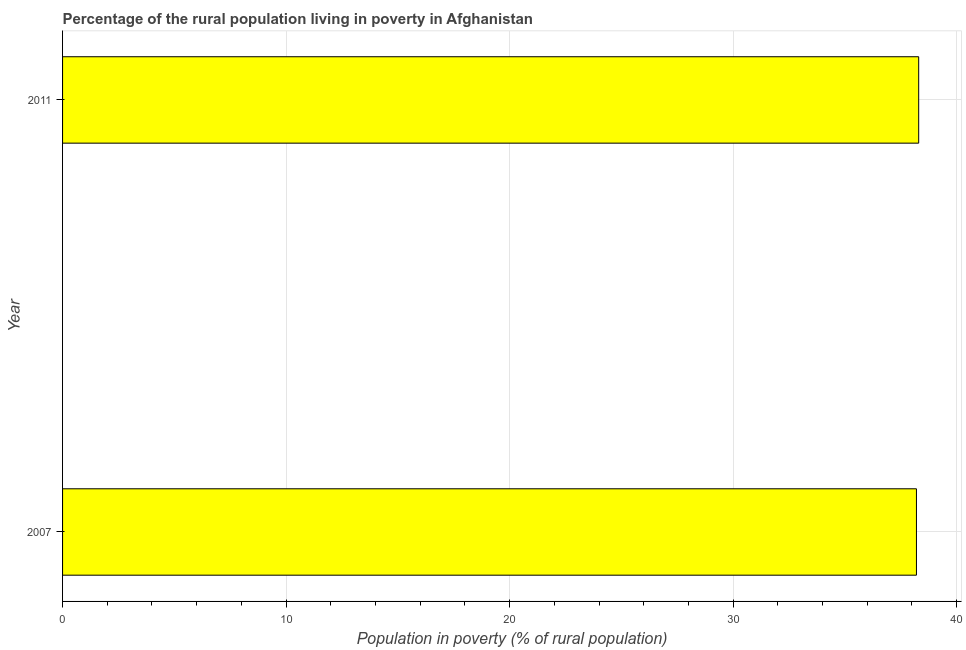Does the graph contain any zero values?
Make the answer very short. No. Does the graph contain grids?
Provide a short and direct response. Yes. What is the title of the graph?
Your response must be concise. Percentage of the rural population living in poverty in Afghanistan. What is the label or title of the X-axis?
Provide a short and direct response. Population in poverty (% of rural population). What is the label or title of the Y-axis?
Your answer should be compact. Year. What is the percentage of rural population living below poverty line in 2011?
Ensure brevity in your answer.  38.3. Across all years, what is the maximum percentage of rural population living below poverty line?
Give a very brief answer. 38.3. Across all years, what is the minimum percentage of rural population living below poverty line?
Give a very brief answer. 38.2. What is the sum of the percentage of rural population living below poverty line?
Your answer should be compact. 76.5. What is the average percentage of rural population living below poverty line per year?
Provide a short and direct response. 38.25. What is the median percentage of rural population living below poverty line?
Your response must be concise. 38.25. In how many years, is the percentage of rural population living below poverty line greater than 16 %?
Give a very brief answer. 2. Is the percentage of rural population living below poverty line in 2007 less than that in 2011?
Your response must be concise. Yes. In how many years, is the percentage of rural population living below poverty line greater than the average percentage of rural population living below poverty line taken over all years?
Give a very brief answer. 1. Are the values on the major ticks of X-axis written in scientific E-notation?
Offer a very short reply. No. What is the Population in poverty (% of rural population) of 2007?
Offer a terse response. 38.2. What is the Population in poverty (% of rural population) in 2011?
Your answer should be very brief. 38.3. What is the difference between the Population in poverty (% of rural population) in 2007 and 2011?
Provide a succinct answer. -0.1. 